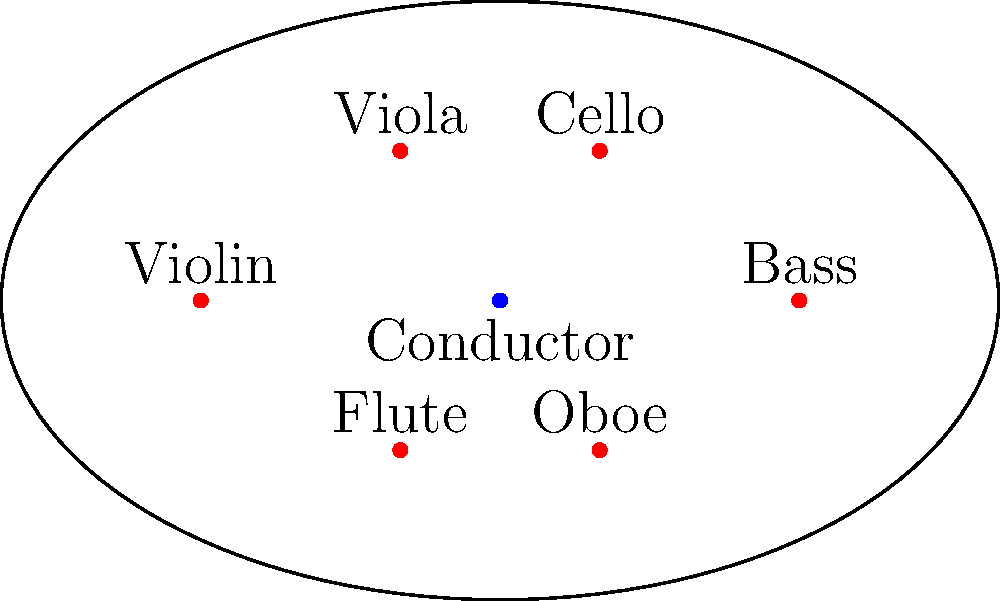In the orchestra pit arrangement shown, which instrument is positioned directly opposite to the Violin, relative to the Conductor? To solve this problem, we need to follow these steps:

1. Identify the position of the Violin in the orchestra pit.
   - The Violin is located at the leftmost position (-6,0).

2. Identify the position of the Conductor.
   - The Conductor is at the center (0,0).

3. Draw an imaginary line from the Violin through the Conductor.
   - This line would extend from (-6,0) through (0,0) to (6,0).

4. Determine which instrument is on this line, opposite to the Violin.
   - Following the line to the right side of the pit, we find the Bass at (6,0).

5. Verify that the Bass is indeed directly opposite to the Violin.
   - The Violin is on the far left, the Bass is on the far right, and they are equidistant from the Conductor.

Therefore, the instrument positioned directly opposite to the Violin, relative to the Conductor, is the Bass.
Answer: Bass 